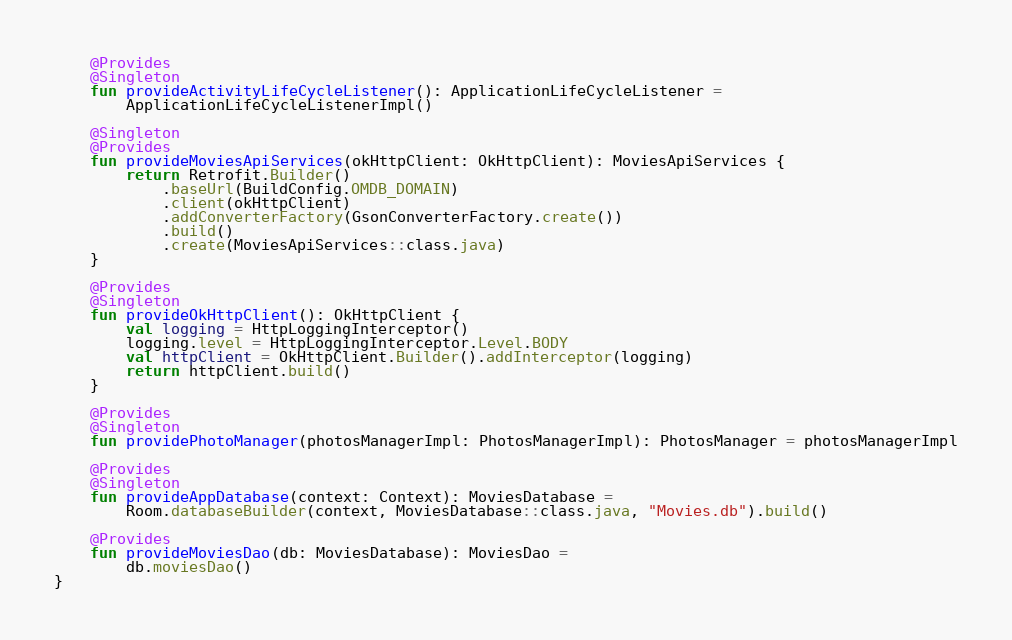<code> <loc_0><loc_0><loc_500><loc_500><_Kotlin_>
    @Provides
    @Singleton
    fun provideActivityLifeCycleListener(): ApplicationLifeCycleListener =
        ApplicationLifeCycleListenerImpl()

    @Singleton
    @Provides
    fun provideMoviesApiServices(okHttpClient: OkHttpClient): MoviesApiServices {
        return Retrofit.Builder()
            .baseUrl(BuildConfig.OMDB_DOMAIN)
            .client(okHttpClient)
            .addConverterFactory(GsonConverterFactory.create())
            .build()
            .create(MoviesApiServices::class.java)
    }

    @Provides
    @Singleton
    fun provideOkHttpClient(): OkHttpClient {
        val logging = HttpLoggingInterceptor()
        logging.level = HttpLoggingInterceptor.Level.BODY
        val httpClient = OkHttpClient.Builder().addInterceptor(logging)
        return httpClient.build()
    }

    @Provides
    @Singleton
    fun providePhotoManager(photosManagerImpl: PhotosManagerImpl): PhotosManager = photosManagerImpl

    @Provides
    @Singleton
    fun provideAppDatabase(context: Context): MoviesDatabase =
        Room.databaseBuilder(context, MoviesDatabase::class.java, "Movies.db").build()

    @Provides
    fun provideMoviesDao(db: MoviesDatabase): MoviesDao =
        db.moviesDao()
}
</code> 